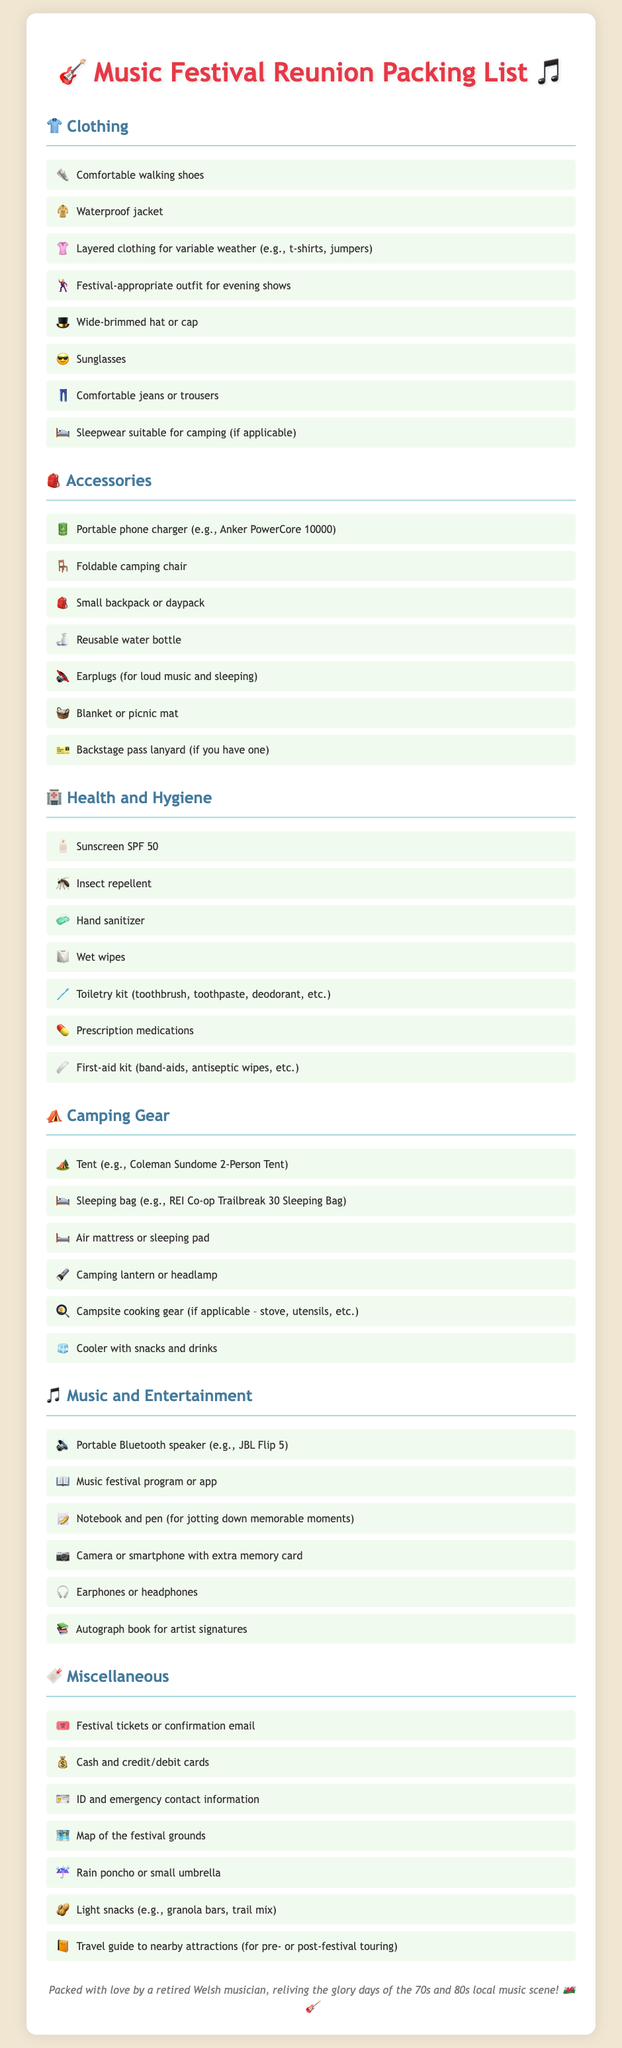What clothing item is suggested for variable weather? The document suggests layered clothing such as t-shirts and jumpers to adapt to changing weather conditions.
Answer: Layered clothing How many main sections are in the packing list? The packing list contains five main sections: Clothing, Accessories, Health and Hygiene, Camping Gear, Music and Entertainment, and Miscellaneous.
Answer: Five What is the recommended sunscreen SPF? The packing list specifies using sunscreen with SPF 50 for protection against sunburn.
Answer: SPF 50 What item is mentioned for seating while camping? The document lists a foldable camping chair as an essential accessory for seating during the festival.
Answer: Foldable camping chair How many music-related items are suggested in the list? The music and entertainment section suggests six different items for enjoyment during the festival.
Answer: Six What type of shoes is recommended for comfort? Comfortable walking shoes are highlighted as a necessary clothing item for the festival.
Answer: Comfortable walking shoes What should you bring for insect protection? Insect repellent is advised in the health and hygiene section to protect against bites.
Answer: Insect repellent What is required for sleeping while camping? The packing list indicates bringing a sleeping bag suitable for outdoor use during camping.
Answer: Sleeping bag What type of personal identification is suggested to carry? The document suggests carrying an ID along with emergency contact information for safety.
Answer: ID 